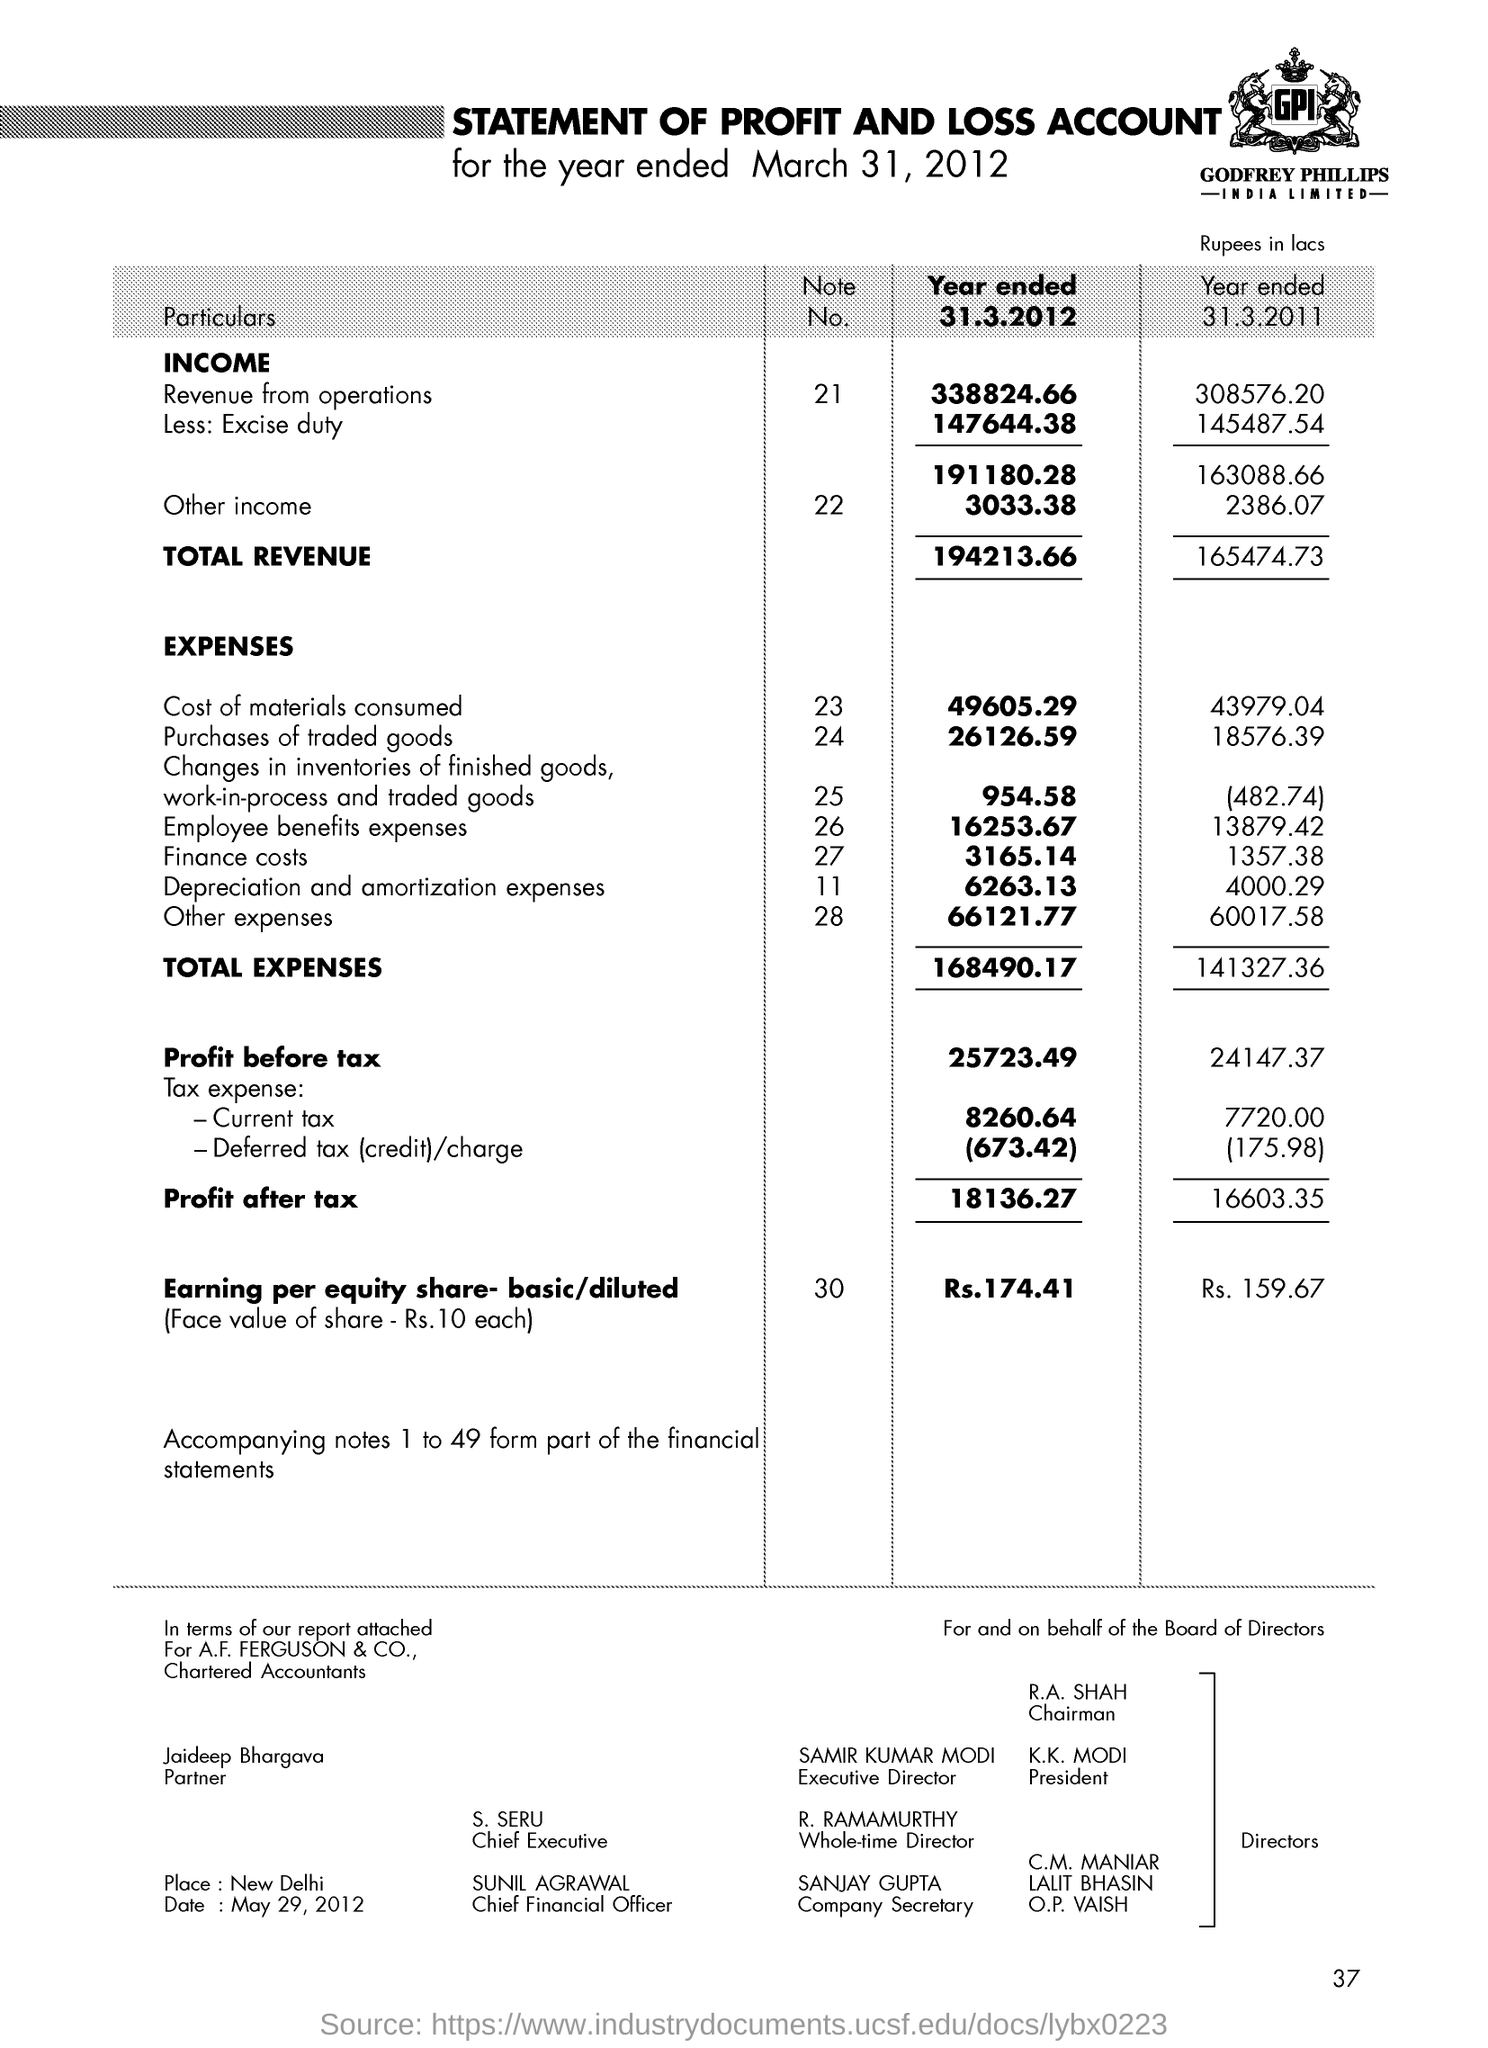Draw attention to some important aspects in this diagram. The revenue from operations for the year ended 31.3.2012 was Rs. 338824.66. The note number for earning per equity share - basic / diluted is 30. The current president of India is Narendra Modi. The note number for the other income is 22. S. SERU is the chief executive. 